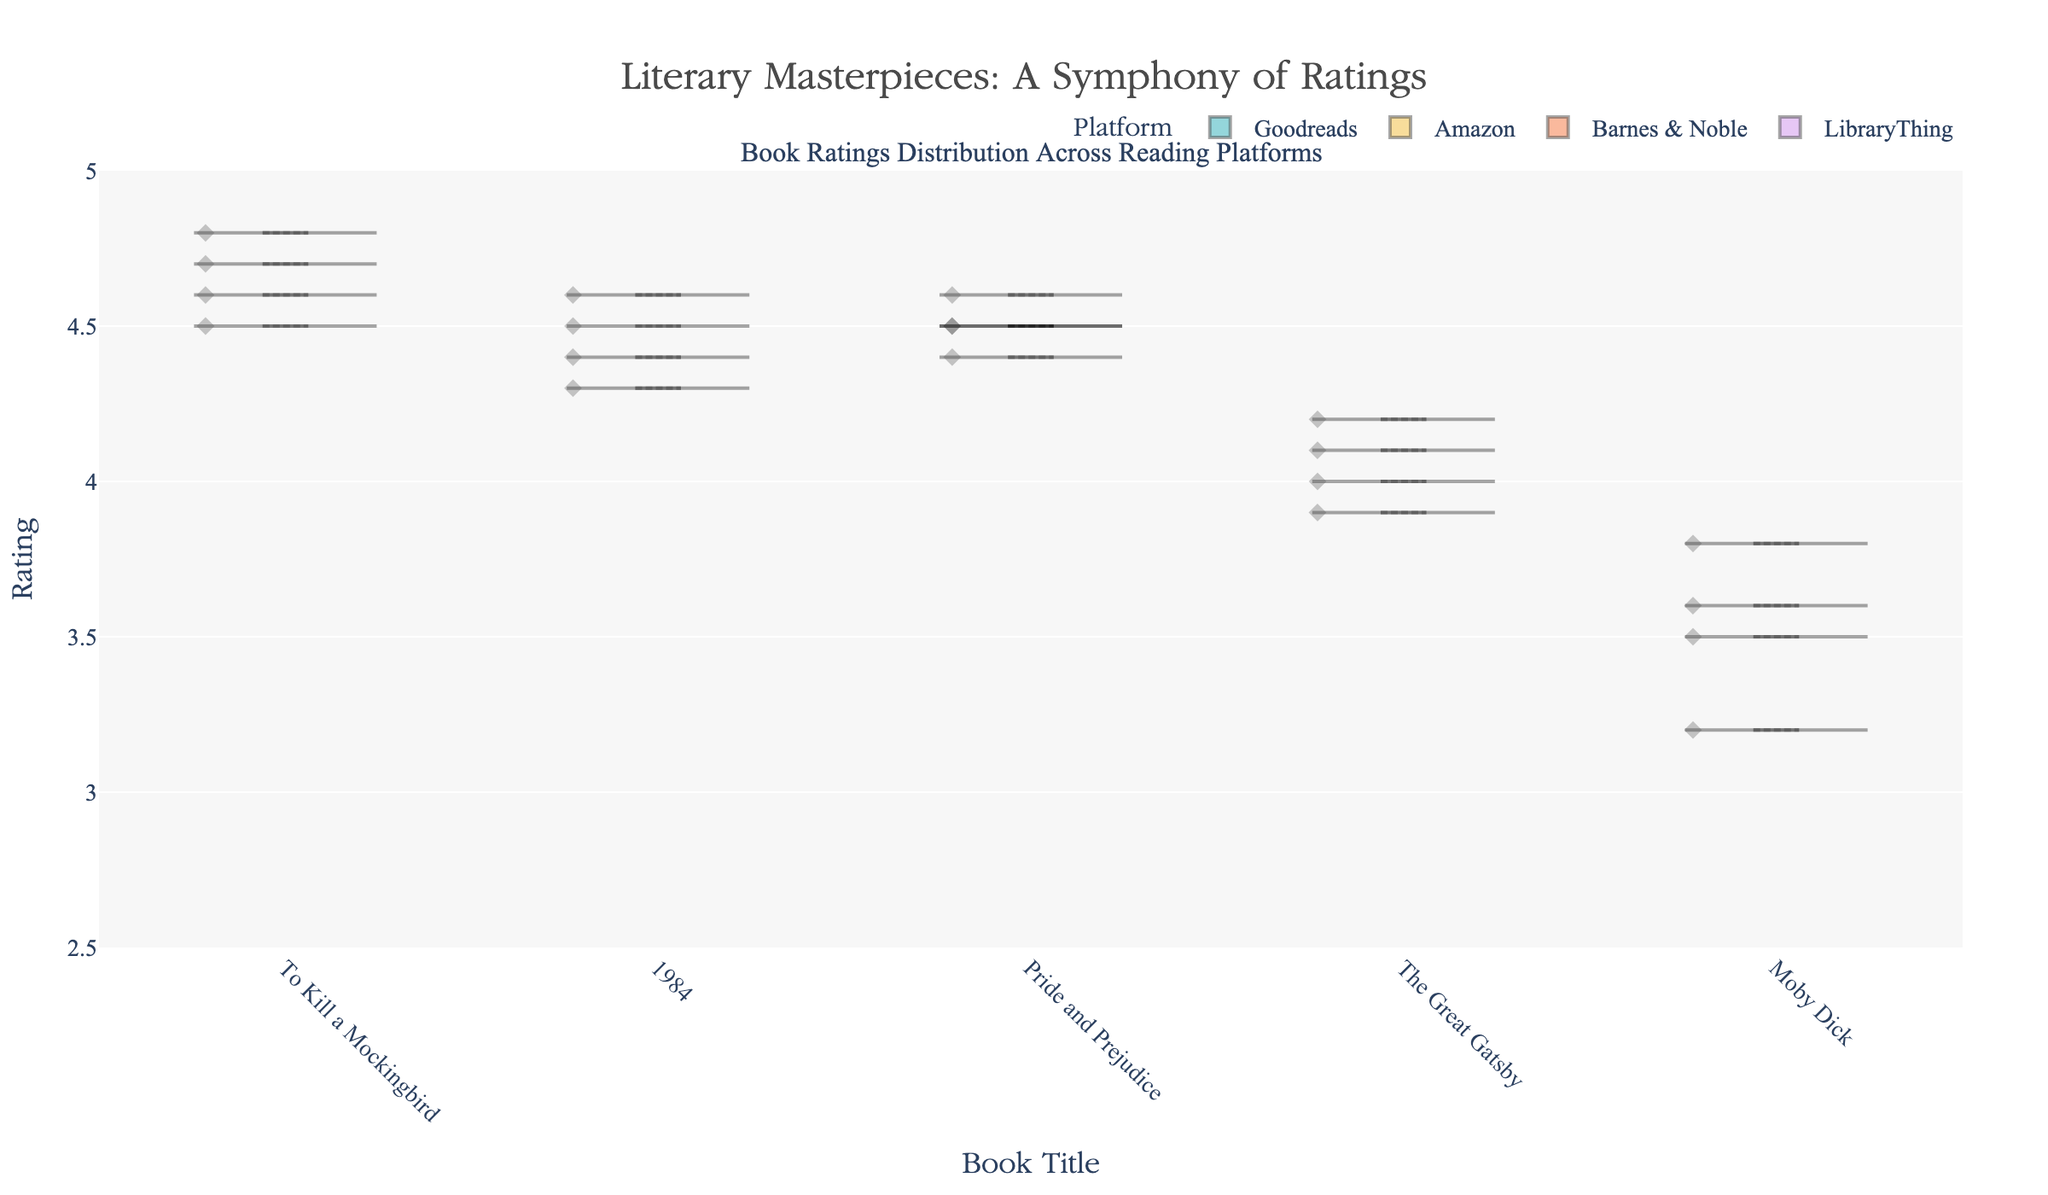What is the title of the chart? The title of the chart is often located at the top, centered. It reads "Literary Masterpieces: A Symphony of Ratings".
Answer: Literary Masterpieces: A Symphony of Ratings Which platform has the lowest rating for "Moby Dick"? Look at the violin plots corresponding to "Moby Dick" for each platform. Identify the lowest point.
Answer: Goodreads How do the ratings for "To Kill a Mockingbird" compare across platforms? Examine the violin plots for "To Kill a Mockingbird". Compare the spread and central tendency (mean line) across different platforms.
Answer: Similar, with slight variations Which book has the highest rating on Amazon? Look at the central line (mean) of Amazon's violin plots for each book. Identify which plot has the highest position.
Answer: 1984 and Pride and Prejudice Across all platforms, which book generally has the widest spread in ratings? Examine the width of the violin plots for each book across all platforms. Wide plots indicate greater spread.
Answer: Moby Dick What is the mean rating for "The Great Gatsby" on Barnes & Noble? Look for the central line (mean line) in the Barnes & Noble's violin plot for "The Great Gatsby".
Answer: 4.1 Comparing the mean ratings of "1984", which platforms have almost equal ratings? Identify the mean lines for "1984" across all platforms. Compare their positions to see which ones are closest.
Answer: Goodreads and LibraryThing Which book has the most consistent high ratings across all platforms? Consistency in high ratings means narrow plots mostly positioned at the top. Examine plots for all books.
Answer: To Kill a Mockingbird How does the spread of ratings for "Pride and Prejudice" on LibraryThing compare to Goodreads? Compare the width and shape of the violin plots for "Pride and Prejudice" on LibraryThing and Goodreads.
Answer: Both are narrow, indicating consistent ratings What is the overall range of ratings shown in the chart? Look at the highest and lowest points across all violin plots. Determine the range by subtracting the lowest rating from the highest.
Answer: 3.2 to 4.8, range 1.6 